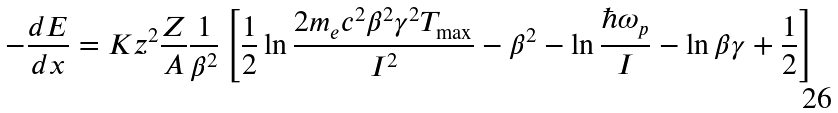<formula> <loc_0><loc_0><loc_500><loc_500>- \frac { d E } { d x } = K z ^ { 2 } \frac { Z } { A } \frac { 1 } { \beta ^ { 2 } } \left [ \frac { 1 } { 2 } \ln \frac { 2 m _ { e } c ^ { 2 } \beta ^ { 2 } \gamma ^ { 2 } T _ { \max } } { I ^ { 2 } } - \beta ^ { 2 } - \ln \frac { \hbar { \omega } _ { p } } { I } - \ln \beta \gamma + \frac { 1 } { 2 } \right ]</formula> 